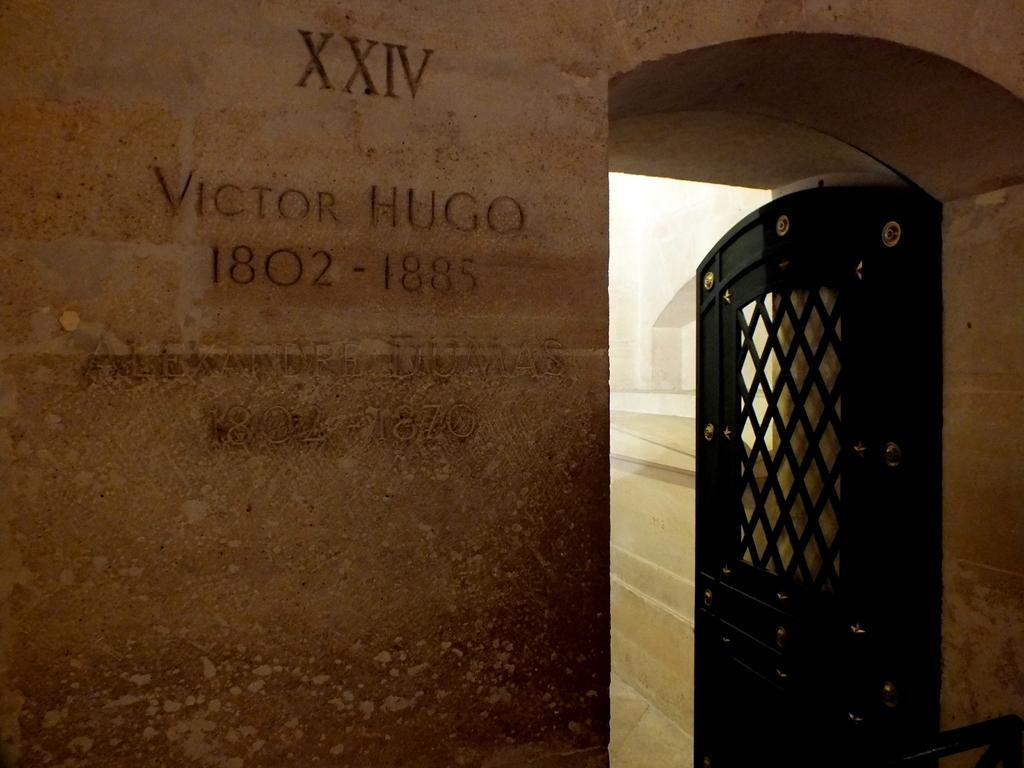What is located on the right side of the image? There is a door on the right side of the image. What can be seen on the left side of the image? There is text and numbers on the wall on the left side of the image. What is visible in the background of the image? The ground is visible in the background of the image. Can you describe any other objects present in the background of the image? There are other objects present in the background of the image, but their specific details are not mentioned in the provided facts. What type of bread is being served in the lunchroom in the image? There is no mention of bread or a lunchroom in the image; it features a door and text and numbers on a wall. What stage of development is depicted in the image? The image does not show any developmental stages or processes; it features a door and text and numbers on a wall. 